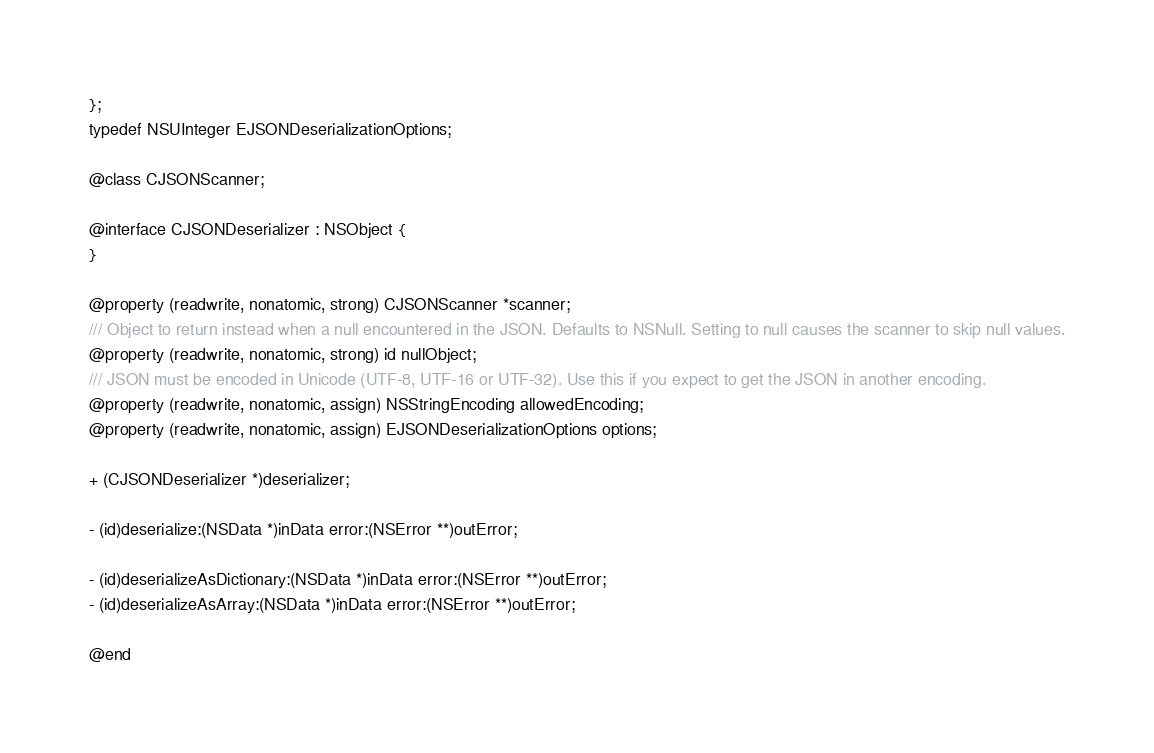<code> <loc_0><loc_0><loc_500><loc_500><_C_>};
typedef NSUInteger EJSONDeserializationOptions;

@class CJSONScanner;

@interface CJSONDeserializer : NSObject {
}

@property (readwrite, nonatomic, strong) CJSONScanner *scanner;
/// Object to return instead when a null encountered in the JSON. Defaults to NSNull. Setting to null causes the scanner to skip null values.
@property (readwrite, nonatomic, strong) id nullObject;
/// JSON must be encoded in Unicode (UTF-8, UTF-16 or UTF-32). Use this if you expect to get the JSON in another encoding.
@property (readwrite, nonatomic, assign) NSStringEncoding allowedEncoding;
@property (readwrite, nonatomic, assign) EJSONDeserializationOptions options;

+ (CJSONDeserializer *)deserializer;

- (id)deserialize:(NSData *)inData error:(NSError **)outError;

- (id)deserializeAsDictionary:(NSData *)inData error:(NSError **)outError;
- (id)deserializeAsArray:(NSData *)inData error:(NSError **)outError;

@end
</code> 